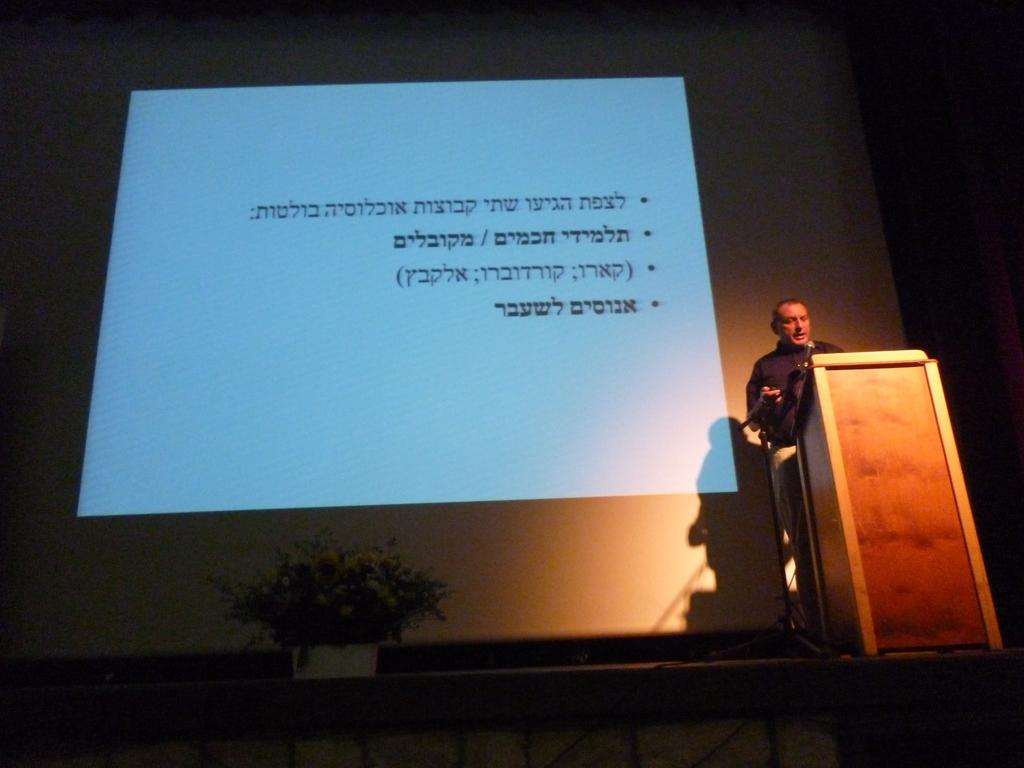What is the person in the image doing? The person is standing in front of the podium. What device is present for the person to speak into? There is a mic in the image. What can be seen in the background behind the person? There is a flowerpot and a screen visible in the background. What type of store can be seen in the background of the image? There is no store present in the image; it only shows a person standing in front of a podium with a mic, a flowerpot, and a screen in the background. 